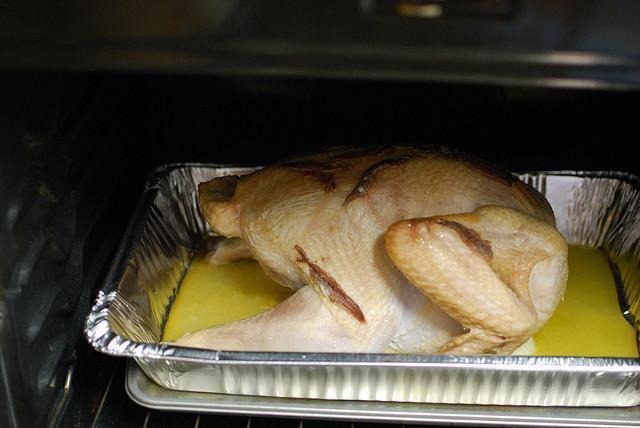How many shirts is the man wearing?
Give a very brief answer. 0. 